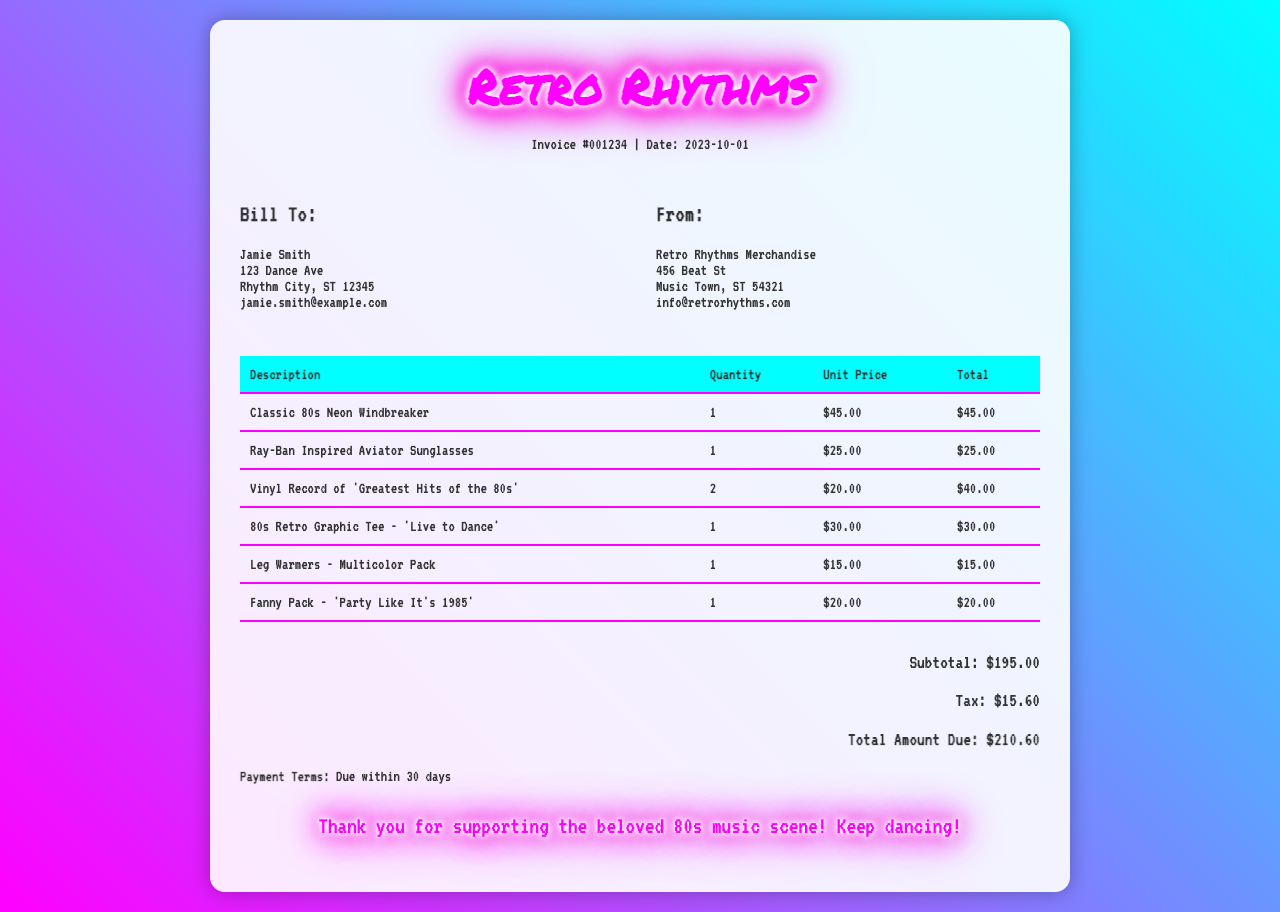What is the invoice number? The invoice number is located at the top of the document, labeled as "Invoice #001234".
Answer: 001234 What is the date of the invoice? The date is found in the header section of the document, next to the invoice number.
Answer: 2023-10-01 Who is the customer? The customer name is listed under the "Bill To:" section.
Answer: Jamie Smith What is the total amount due? The total amount due is found at the bottom of the invoice, below the subtotal and tax.
Answer: $210.60 How many 'Vinyl Record of 'Greatest Hits of the 80s' were purchased? The quantity is listed in the table under the corresponding description.
Answer: 2 What is the subtotal before tax? The subtotal can be identified in the total section of the invoice, before tax is added.
Answer: $195.00 What is the email address of the customer? The email is listed in the customer details section of the document.
Answer: jamie.smith@example.com What is the payment term for the invoice? The payment terms can be found towards the end of the document under the payment terms section.
Answer: Due within 30 days What type of merchandise is the 'Fanny Pack'? The merchandise type is specified in the table under the corresponding item description.
Answer: Accessory 